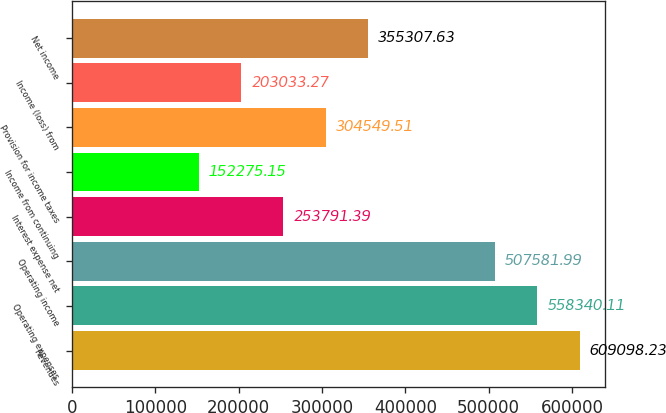Convert chart to OTSL. <chart><loc_0><loc_0><loc_500><loc_500><bar_chart><fcel>Revenues<fcel>Operating expenses<fcel>Operating income<fcel>Interest expense net<fcel>Income from continuing<fcel>Provision for income taxes<fcel>Income (loss) from<fcel>Net income<nl><fcel>609098<fcel>558340<fcel>507582<fcel>253791<fcel>152275<fcel>304550<fcel>203033<fcel>355308<nl></chart> 